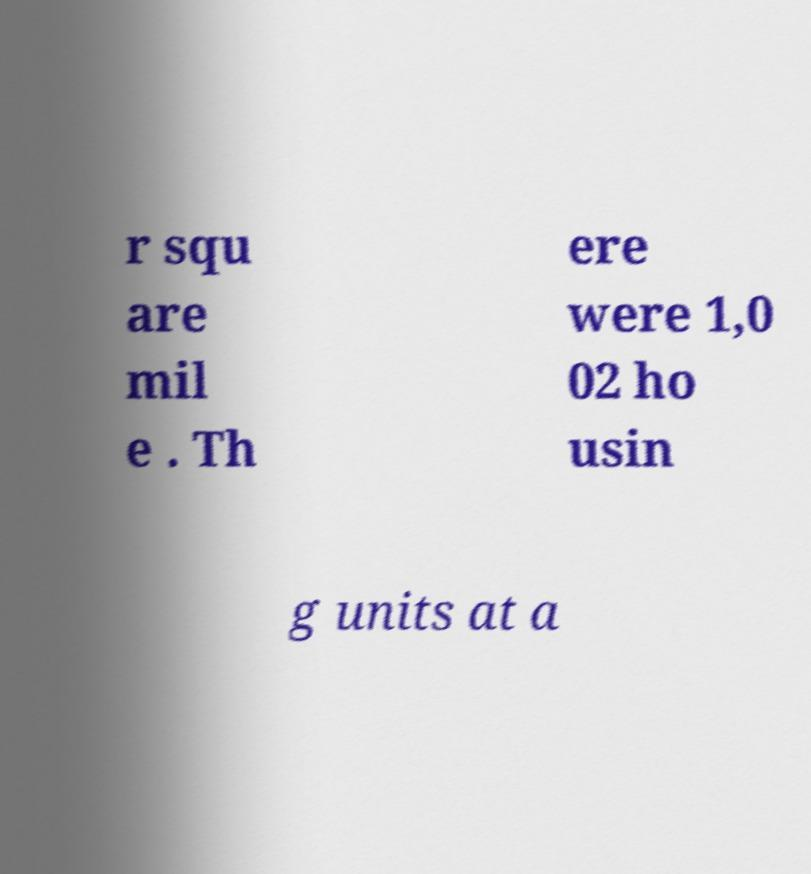I need the written content from this picture converted into text. Can you do that? r squ are mil e . Th ere were 1,0 02 ho usin g units at a 